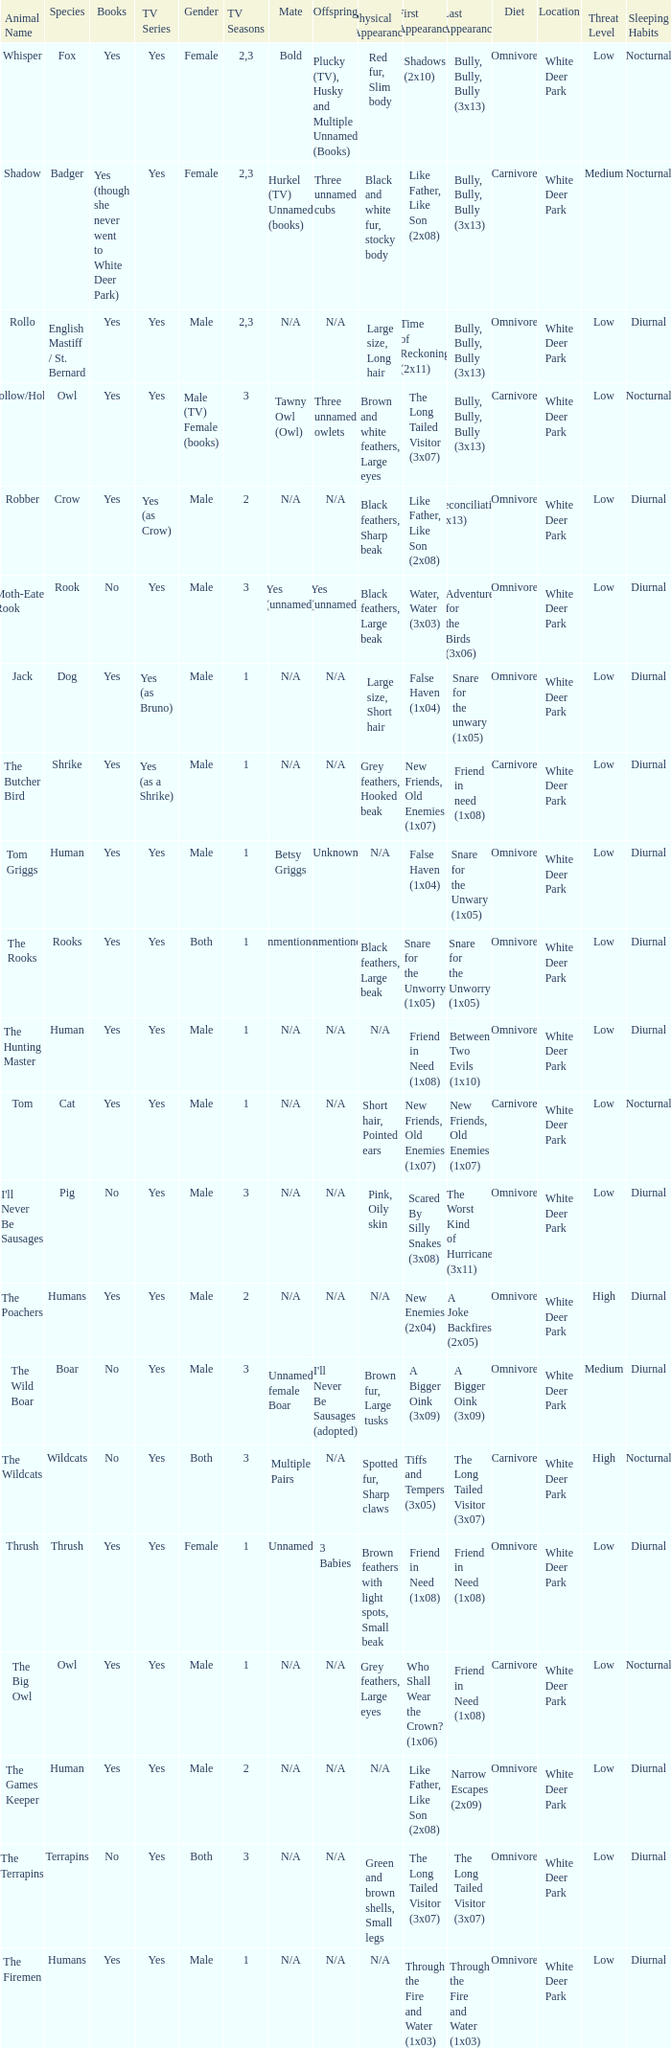Can you give me this table as a dict? {'header': ['Animal Name', 'Species', 'Books', 'TV Series', 'Gender', 'TV Seasons', 'Mate', 'Offspring', 'Physical Appearance', 'First Appearance', 'Last Appearance', 'Diet', 'Location', 'Threat Level', 'Sleeping Habits'], 'rows': [['Whisper', 'Fox', 'Yes', 'Yes', 'Female', '2,3', 'Bold', 'Plucky (TV), Husky and Multiple Unnamed (Books)', 'Red fur, Slim body', 'Shadows (2x10)', 'Bully, Bully, Bully (3x13)', 'Omnivore', 'White Deer Park', 'Low', 'Nocturnal'], ['Shadow', 'Badger', 'Yes (though she never went to White Deer Park)', 'Yes', 'Female', '2,3', 'Hurkel (TV) Unnamed (books)', 'Three unnamed cubs', 'Black and white fur, stocky body', 'Like Father, Like Son (2x08)', 'Bully, Bully, Bully (3x13)', 'Carnivore', 'White Deer Park', 'Medium', 'Nocturnal'], ['Rollo', 'English Mastiff / St. Bernard', 'Yes', 'Yes', 'Male', '2,3', 'N/A', 'N/A', 'Large size, Long hair', 'Time of Reckoning (2x11)', 'Bully, Bully, Bully (3x13)', 'Omnivore', 'White Deer Park', 'Low', 'Diurnal'], ['Hollow/Holly', 'Owl', 'Yes', 'Yes', 'Male (TV) Female (books)', '3', 'Tawny Owl (Owl)', 'Three unnamed owlets', 'Brown and white feathers, Large eyes', 'The Long Tailed Visitor (3x07)', 'Bully, Bully, Bully (3x13)', 'Carnivore', 'White Deer Park', 'Low', 'Nocturnal'], ['Robber', 'Crow', 'Yes', 'Yes (as Crow)', 'Male', '2', 'N/A', 'N/A', 'Black feathers, Sharp beak', 'Like Father, Like Son (2x08)', 'Reconciliation (2x13)', 'Omnivore', 'White Deer Park', 'Low', 'Diurnal'], ['Moth-Eaten Rook', 'Rook', 'No', 'Yes', 'Male', '3', 'Yes (unnamed)', 'Yes (unnamed)', 'Black feathers, Large beak', 'Water, Water (3x03)', 'Adventure for the Birds (3x06)', 'Omnivore', 'White Deer Park', 'Low', 'Diurnal'], ['Jack', 'Dog', 'Yes', 'Yes (as Bruno)', 'Male', '1', 'N/A', 'N/A', 'Large size, Short hair', 'False Haven (1x04)', 'Snare for the unwary (1x05)', 'Omnivore', 'White Deer Park', 'Low', 'Diurnal'], ['The Butcher Bird', 'Shrike', 'Yes', 'Yes (as a Shrike)', 'Male', '1', 'N/A', 'N/A', 'Grey feathers, Hooked beak', 'New Friends, Old Enemies (1x07)', 'Friend in need (1x08)', 'Carnivore', 'White Deer Park', 'Low', 'Diurnal'], ['Tom Griggs', 'Human', 'Yes', 'Yes', 'Male', '1', 'Betsy Griggs', 'Unknown', 'N/A', 'False Haven (1x04)', 'Snare for the Unwary (1x05)', 'Omnivore', 'White Deer Park', 'Low', 'Diurnal'], ['The Rooks', 'Rooks', 'Yes', 'Yes', 'Both', '1', 'Unmentioned', 'Unmentioned', 'Black feathers, Large beak', 'Snare for the Unworry (1x05)', 'Snare for the Unworry (1x05)', 'Omnivore', 'White Deer Park', 'Low', 'Diurnal'], ['The Hunting Master', 'Human', 'Yes', 'Yes', 'Male', '1', 'N/A', 'N/A', 'N/A', 'Friend in Need (1x08)', 'Between Two Evils (1x10)', 'Omnivore', 'White Deer Park', 'Low', 'Diurnal'], ['Tom', 'Cat', 'Yes', 'Yes', 'Male', '1', 'N/A', 'N/A', 'Short hair, Pointed ears', 'New Friends, Old Enemies (1x07)', 'New Friends, Old Enemies (1x07)', 'Carnivore', 'White Deer Park', 'Low', 'Nocturnal'], ["I'll Never Be Sausages", 'Pig', 'No', 'Yes', 'Male', '3', 'N/A', 'N/A', 'Pink, Oily skin', 'Scared By Silly Snakes (3x08)', 'The Worst Kind of Hurricane (3x11)', 'Omnivore', 'White Deer Park', 'Low', 'Diurnal'], ['The Poachers', 'Humans', 'Yes', 'Yes', 'Male', '2', 'N/A', 'N/A', 'N/A', 'New Enemies (2x04)', 'A Joke Backfires (2x05)', 'Omnivore', 'White Deer Park', 'High', 'Diurnal'], ['The Wild Boar', 'Boar', 'No', 'Yes', 'Male', '3', 'Unnamed female Boar', "I'll Never Be Sausages (adopted)", 'Brown fur, Large tusks', 'A Bigger Oink (3x09)', 'A Bigger Oink (3x09)', 'Omnivore', 'White Deer Park', 'Medium', 'Diurnal'], ['The Wildcats', 'Wildcats', 'No', 'Yes', 'Both', '3', 'Multiple Pairs', 'N/A', 'Spotted fur, Sharp claws', 'Tiffs and Tempers (3x05)', 'The Long Tailed Visitor (3x07)', 'Carnivore', 'White Deer Park', 'High', 'Nocturnal'], ['Thrush', 'Thrush', 'Yes', 'Yes', 'Female', '1', 'Unnamed', '3 Babies', 'Brown feathers with light spots, Small beak', 'Friend in Need (1x08)', 'Friend in Need (1x08)', 'Omnivore', 'White Deer Park', 'Low', 'Diurnal'], ['The Big Owl', 'Owl', 'Yes', 'Yes', 'Male', '1', 'N/A', 'N/A', 'Grey feathers, Large eyes', 'Who Shall Wear the Crown? (1x06)', 'Friend in Need (1x08)', 'Carnivore', 'White Deer Park', 'Low', 'Nocturnal'], ['The Games Keeper', 'Human', 'Yes', 'Yes', 'Male', '2', 'N/A', 'N/A', 'N/A', 'Like Father, Like Son (2x08)', 'Narrow Escapes (2x09)', 'Omnivore', 'White Deer Park', 'Low', 'Diurnal'], ['The Terrapins', 'Terrapins', 'No', 'Yes', 'Both', '3', 'N/A', 'N/A', 'Green and brown shells, Small legs', 'The Long Tailed Visitor (3x07)', 'The Long Tailed Visitor (3x07)', 'Omnivore', 'White Deer Park', 'Low', 'Diurnal'], ['The Firemen', 'Humans', 'Yes', 'Yes', 'Male', '1', 'N/A', 'N/A', 'N/A', 'Through the Fire and Water (1x03)', 'Through the Fire and Water (1x03)', 'Omnivore', 'White Deer Park', 'Low', 'Diurnal']]} What is the mate for Last Appearance of bully, bully, bully (3x13) for the animal named hollow/holly later than season 1? Tawny Owl (Owl). 